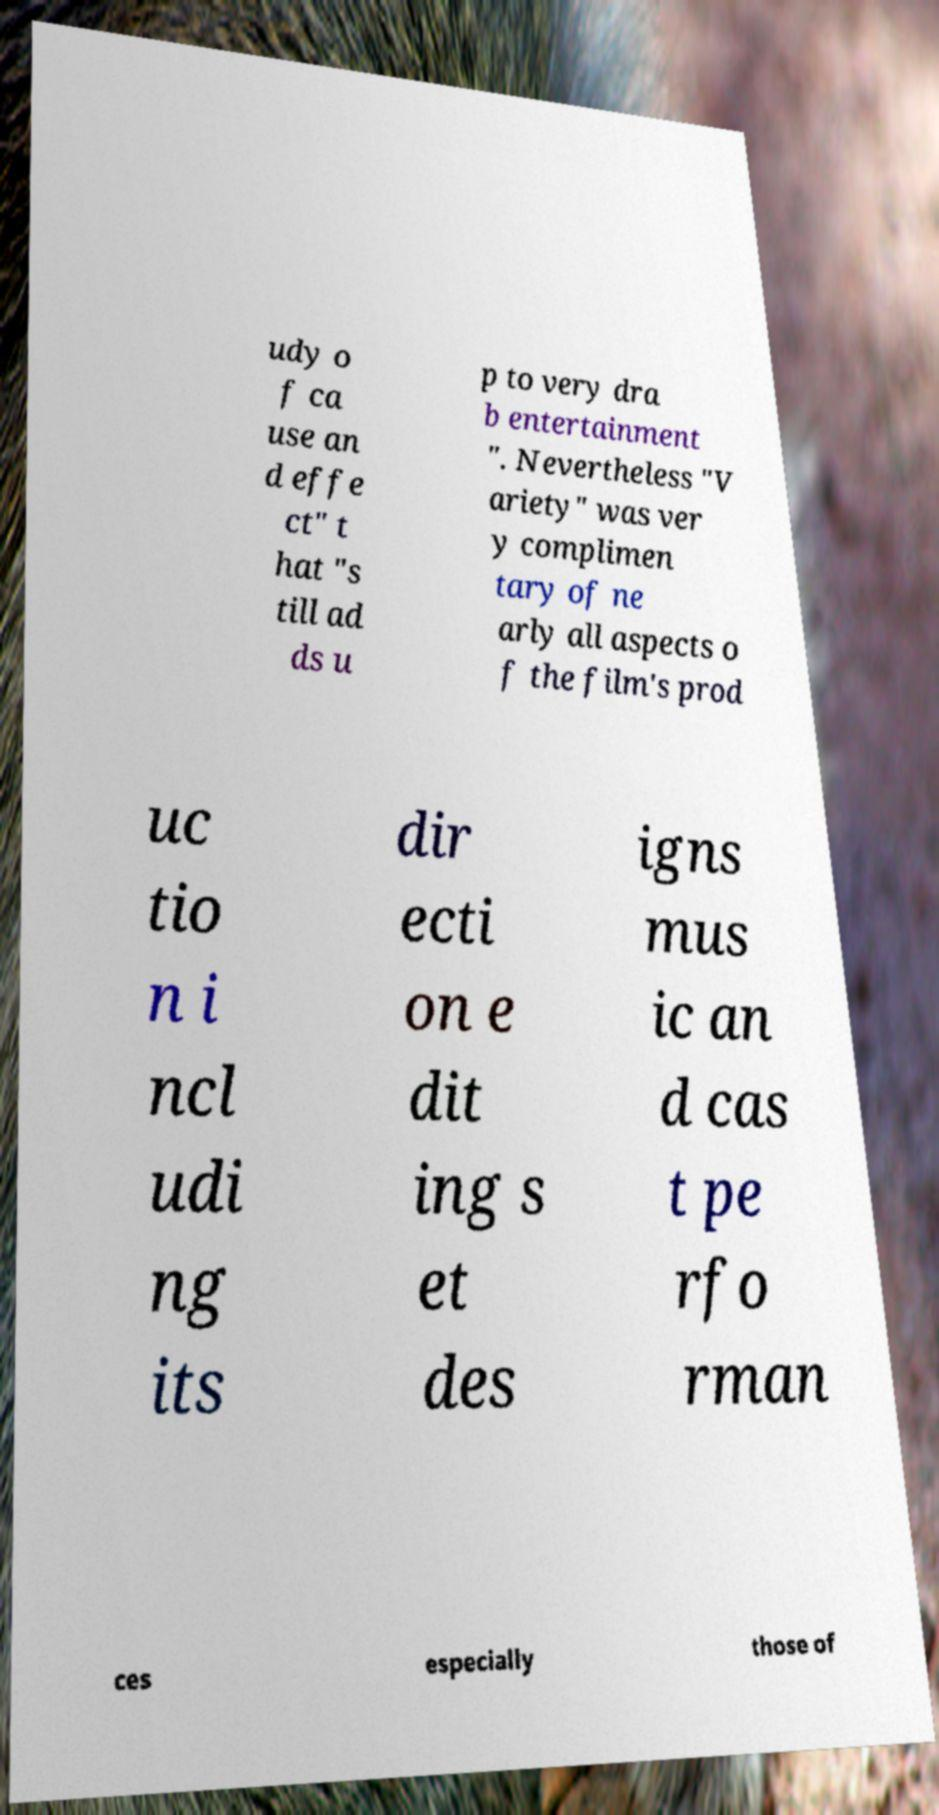I need the written content from this picture converted into text. Can you do that? udy o f ca use an d effe ct" t hat "s till ad ds u p to very dra b entertainment ". Nevertheless "V ariety" was ver y complimen tary of ne arly all aspects o f the film's prod uc tio n i ncl udi ng its dir ecti on e dit ing s et des igns mus ic an d cas t pe rfo rman ces especially those of 